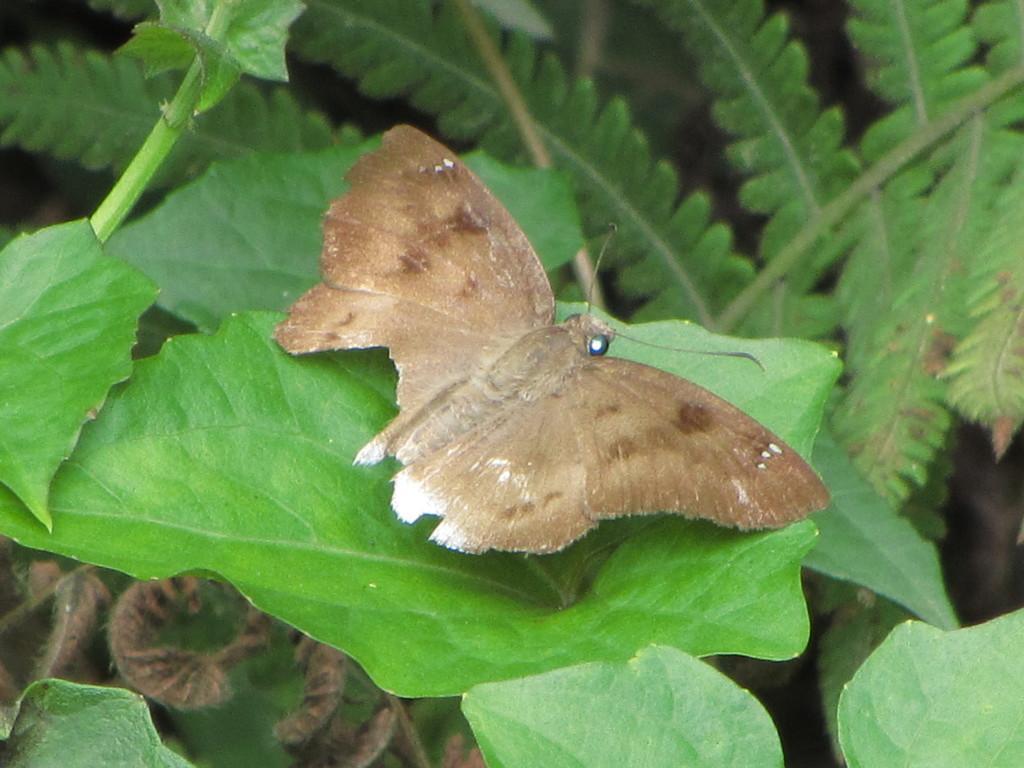Could you give a brief overview of what you see in this image? In this picture I can see a brown color butterfly on the leaf and I can see trees. 